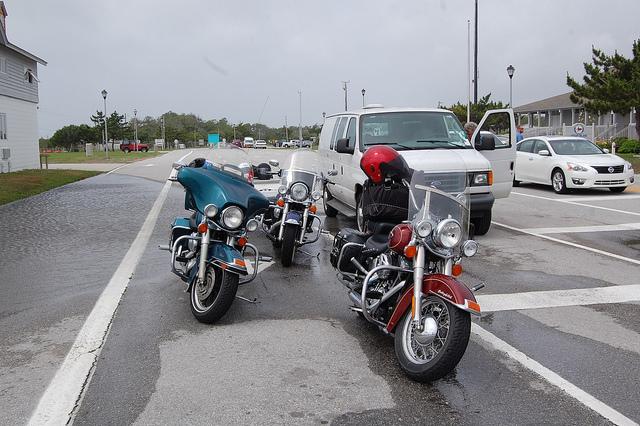Are these motorcycles parked in parking spaces?
Answer briefly. No. How many motorcycles have riders?
Write a very short answer. 0. Are there any cones in the picture?
Short answer required. No. How many cars are pictured?
Quick response, please. 2. Which color motorcycle has a noticeable helmet on the seat?
Keep it brief. Red. How many people are on the motorcycle?
Keep it brief. 0. 